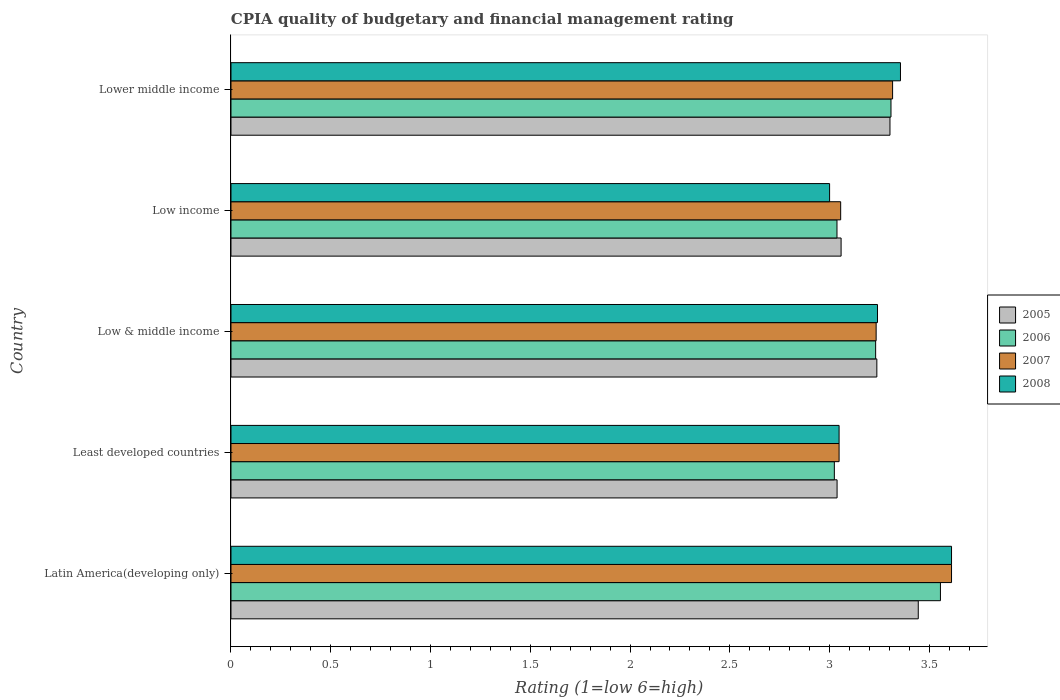How many different coloured bars are there?
Ensure brevity in your answer.  4. How many groups of bars are there?
Your answer should be compact. 5. How many bars are there on the 4th tick from the top?
Give a very brief answer. 4. What is the label of the 2nd group of bars from the top?
Your answer should be very brief. Low income. What is the CPIA rating in 2005 in Latin America(developing only)?
Provide a succinct answer. 3.44. Across all countries, what is the maximum CPIA rating in 2005?
Offer a terse response. 3.44. Across all countries, what is the minimum CPIA rating in 2005?
Make the answer very short. 3.04. In which country was the CPIA rating in 2007 maximum?
Your response must be concise. Latin America(developing only). In which country was the CPIA rating in 2006 minimum?
Make the answer very short. Least developed countries. What is the total CPIA rating in 2006 in the graph?
Your answer should be compact. 16.15. What is the difference between the CPIA rating in 2008 in Latin America(developing only) and that in Lower middle income?
Offer a terse response. 0.26. What is the difference between the CPIA rating in 2007 in Lower middle income and the CPIA rating in 2005 in Least developed countries?
Your response must be concise. 0.28. What is the average CPIA rating in 2007 per country?
Your answer should be compact. 3.25. What is the difference between the CPIA rating in 2005 and CPIA rating in 2007 in Lower middle income?
Your response must be concise. -0.01. In how many countries, is the CPIA rating in 2006 greater than 2.4 ?
Ensure brevity in your answer.  5. What is the ratio of the CPIA rating in 2005 in Low & middle income to that in Low income?
Your answer should be compact. 1.06. What is the difference between the highest and the second highest CPIA rating in 2005?
Offer a very short reply. 0.14. What is the difference between the highest and the lowest CPIA rating in 2005?
Your response must be concise. 0.41. In how many countries, is the CPIA rating in 2007 greater than the average CPIA rating in 2007 taken over all countries?
Offer a terse response. 2. Is the sum of the CPIA rating in 2007 in Latin America(developing only) and Low income greater than the maximum CPIA rating in 2005 across all countries?
Offer a terse response. Yes. Is it the case that in every country, the sum of the CPIA rating in 2005 and CPIA rating in 2008 is greater than the sum of CPIA rating in 2007 and CPIA rating in 2006?
Provide a succinct answer. No. What does the 3rd bar from the top in Low & middle income represents?
Provide a succinct answer. 2006. What does the 2nd bar from the bottom in Least developed countries represents?
Provide a succinct answer. 2006. Is it the case that in every country, the sum of the CPIA rating in 2006 and CPIA rating in 2008 is greater than the CPIA rating in 2007?
Make the answer very short. Yes. Are all the bars in the graph horizontal?
Ensure brevity in your answer.  Yes. How many countries are there in the graph?
Your answer should be compact. 5. What is the difference between two consecutive major ticks on the X-axis?
Provide a short and direct response. 0.5. Are the values on the major ticks of X-axis written in scientific E-notation?
Your answer should be very brief. No. Does the graph contain grids?
Provide a short and direct response. No. Where does the legend appear in the graph?
Make the answer very short. Center right. How are the legend labels stacked?
Give a very brief answer. Vertical. What is the title of the graph?
Offer a very short reply. CPIA quality of budgetary and financial management rating. What is the Rating (1=low 6=high) of 2005 in Latin America(developing only)?
Ensure brevity in your answer.  3.44. What is the Rating (1=low 6=high) in 2006 in Latin America(developing only)?
Ensure brevity in your answer.  3.56. What is the Rating (1=low 6=high) of 2007 in Latin America(developing only)?
Your response must be concise. 3.61. What is the Rating (1=low 6=high) of 2008 in Latin America(developing only)?
Provide a succinct answer. 3.61. What is the Rating (1=low 6=high) of 2005 in Least developed countries?
Offer a terse response. 3.04. What is the Rating (1=low 6=high) in 2006 in Least developed countries?
Keep it short and to the point. 3.02. What is the Rating (1=low 6=high) of 2007 in Least developed countries?
Provide a short and direct response. 3.05. What is the Rating (1=low 6=high) in 2008 in Least developed countries?
Provide a succinct answer. 3.05. What is the Rating (1=low 6=high) of 2005 in Low & middle income?
Provide a succinct answer. 3.24. What is the Rating (1=low 6=high) of 2006 in Low & middle income?
Give a very brief answer. 3.23. What is the Rating (1=low 6=high) of 2007 in Low & middle income?
Offer a very short reply. 3.23. What is the Rating (1=low 6=high) of 2008 in Low & middle income?
Provide a succinct answer. 3.24. What is the Rating (1=low 6=high) in 2005 in Low income?
Provide a succinct answer. 3.06. What is the Rating (1=low 6=high) of 2006 in Low income?
Make the answer very short. 3.04. What is the Rating (1=low 6=high) of 2007 in Low income?
Provide a succinct answer. 3.06. What is the Rating (1=low 6=high) of 2008 in Low income?
Offer a terse response. 3. What is the Rating (1=low 6=high) in 2005 in Lower middle income?
Your answer should be very brief. 3.3. What is the Rating (1=low 6=high) of 2006 in Lower middle income?
Your answer should be very brief. 3.31. What is the Rating (1=low 6=high) of 2007 in Lower middle income?
Give a very brief answer. 3.32. What is the Rating (1=low 6=high) in 2008 in Lower middle income?
Your answer should be very brief. 3.36. Across all countries, what is the maximum Rating (1=low 6=high) of 2005?
Your answer should be compact. 3.44. Across all countries, what is the maximum Rating (1=low 6=high) of 2006?
Your response must be concise. 3.56. Across all countries, what is the maximum Rating (1=low 6=high) in 2007?
Keep it short and to the point. 3.61. Across all countries, what is the maximum Rating (1=low 6=high) of 2008?
Ensure brevity in your answer.  3.61. Across all countries, what is the minimum Rating (1=low 6=high) in 2005?
Give a very brief answer. 3.04. Across all countries, what is the minimum Rating (1=low 6=high) in 2006?
Give a very brief answer. 3.02. Across all countries, what is the minimum Rating (1=low 6=high) in 2007?
Your response must be concise. 3.05. Across all countries, what is the minimum Rating (1=low 6=high) in 2008?
Offer a terse response. 3. What is the total Rating (1=low 6=high) of 2005 in the graph?
Offer a terse response. 16.08. What is the total Rating (1=low 6=high) in 2006 in the graph?
Your response must be concise. 16.15. What is the total Rating (1=low 6=high) in 2007 in the graph?
Ensure brevity in your answer.  16.26. What is the total Rating (1=low 6=high) of 2008 in the graph?
Make the answer very short. 16.25. What is the difference between the Rating (1=low 6=high) of 2005 in Latin America(developing only) and that in Least developed countries?
Give a very brief answer. 0.41. What is the difference between the Rating (1=low 6=high) of 2006 in Latin America(developing only) and that in Least developed countries?
Give a very brief answer. 0.53. What is the difference between the Rating (1=low 6=high) in 2007 in Latin America(developing only) and that in Least developed countries?
Make the answer very short. 0.56. What is the difference between the Rating (1=low 6=high) of 2008 in Latin America(developing only) and that in Least developed countries?
Your answer should be very brief. 0.56. What is the difference between the Rating (1=low 6=high) in 2005 in Latin America(developing only) and that in Low & middle income?
Give a very brief answer. 0.21. What is the difference between the Rating (1=low 6=high) in 2006 in Latin America(developing only) and that in Low & middle income?
Provide a succinct answer. 0.32. What is the difference between the Rating (1=low 6=high) in 2007 in Latin America(developing only) and that in Low & middle income?
Your answer should be compact. 0.38. What is the difference between the Rating (1=low 6=high) in 2008 in Latin America(developing only) and that in Low & middle income?
Your answer should be compact. 0.37. What is the difference between the Rating (1=low 6=high) in 2005 in Latin America(developing only) and that in Low income?
Offer a terse response. 0.39. What is the difference between the Rating (1=low 6=high) of 2006 in Latin America(developing only) and that in Low income?
Provide a short and direct response. 0.52. What is the difference between the Rating (1=low 6=high) in 2007 in Latin America(developing only) and that in Low income?
Ensure brevity in your answer.  0.56. What is the difference between the Rating (1=low 6=high) of 2008 in Latin America(developing only) and that in Low income?
Provide a short and direct response. 0.61. What is the difference between the Rating (1=low 6=high) in 2005 in Latin America(developing only) and that in Lower middle income?
Provide a succinct answer. 0.14. What is the difference between the Rating (1=low 6=high) in 2006 in Latin America(developing only) and that in Lower middle income?
Offer a very short reply. 0.25. What is the difference between the Rating (1=low 6=high) in 2007 in Latin America(developing only) and that in Lower middle income?
Your answer should be compact. 0.3. What is the difference between the Rating (1=low 6=high) in 2008 in Latin America(developing only) and that in Lower middle income?
Offer a very short reply. 0.26. What is the difference between the Rating (1=low 6=high) of 2005 in Least developed countries and that in Low & middle income?
Make the answer very short. -0.2. What is the difference between the Rating (1=low 6=high) of 2006 in Least developed countries and that in Low & middle income?
Your answer should be compact. -0.21. What is the difference between the Rating (1=low 6=high) in 2007 in Least developed countries and that in Low & middle income?
Provide a short and direct response. -0.19. What is the difference between the Rating (1=low 6=high) in 2008 in Least developed countries and that in Low & middle income?
Give a very brief answer. -0.19. What is the difference between the Rating (1=low 6=high) of 2005 in Least developed countries and that in Low income?
Give a very brief answer. -0.02. What is the difference between the Rating (1=low 6=high) in 2006 in Least developed countries and that in Low income?
Keep it short and to the point. -0.01. What is the difference between the Rating (1=low 6=high) in 2007 in Least developed countries and that in Low income?
Offer a very short reply. -0.01. What is the difference between the Rating (1=low 6=high) in 2008 in Least developed countries and that in Low income?
Your answer should be compact. 0.05. What is the difference between the Rating (1=low 6=high) in 2005 in Least developed countries and that in Lower middle income?
Provide a short and direct response. -0.27. What is the difference between the Rating (1=low 6=high) in 2006 in Least developed countries and that in Lower middle income?
Offer a terse response. -0.28. What is the difference between the Rating (1=low 6=high) of 2007 in Least developed countries and that in Lower middle income?
Give a very brief answer. -0.27. What is the difference between the Rating (1=low 6=high) in 2008 in Least developed countries and that in Lower middle income?
Offer a terse response. -0.31. What is the difference between the Rating (1=low 6=high) in 2005 in Low & middle income and that in Low income?
Ensure brevity in your answer.  0.18. What is the difference between the Rating (1=low 6=high) of 2006 in Low & middle income and that in Low income?
Your answer should be compact. 0.19. What is the difference between the Rating (1=low 6=high) in 2007 in Low & middle income and that in Low income?
Give a very brief answer. 0.18. What is the difference between the Rating (1=low 6=high) of 2008 in Low & middle income and that in Low income?
Provide a short and direct response. 0.24. What is the difference between the Rating (1=low 6=high) in 2005 in Low & middle income and that in Lower middle income?
Make the answer very short. -0.07. What is the difference between the Rating (1=low 6=high) of 2006 in Low & middle income and that in Lower middle income?
Your answer should be very brief. -0.08. What is the difference between the Rating (1=low 6=high) of 2007 in Low & middle income and that in Lower middle income?
Your response must be concise. -0.08. What is the difference between the Rating (1=low 6=high) in 2008 in Low & middle income and that in Lower middle income?
Make the answer very short. -0.12. What is the difference between the Rating (1=low 6=high) of 2005 in Low income and that in Lower middle income?
Give a very brief answer. -0.24. What is the difference between the Rating (1=low 6=high) in 2006 in Low income and that in Lower middle income?
Make the answer very short. -0.27. What is the difference between the Rating (1=low 6=high) of 2007 in Low income and that in Lower middle income?
Keep it short and to the point. -0.26. What is the difference between the Rating (1=low 6=high) in 2008 in Low income and that in Lower middle income?
Keep it short and to the point. -0.36. What is the difference between the Rating (1=low 6=high) of 2005 in Latin America(developing only) and the Rating (1=low 6=high) of 2006 in Least developed countries?
Offer a very short reply. 0.42. What is the difference between the Rating (1=low 6=high) of 2005 in Latin America(developing only) and the Rating (1=low 6=high) of 2007 in Least developed countries?
Your answer should be very brief. 0.4. What is the difference between the Rating (1=low 6=high) in 2005 in Latin America(developing only) and the Rating (1=low 6=high) in 2008 in Least developed countries?
Provide a succinct answer. 0.4. What is the difference between the Rating (1=low 6=high) of 2006 in Latin America(developing only) and the Rating (1=low 6=high) of 2007 in Least developed countries?
Provide a succinct answer. 0.51. What is the difference between the Rating (1=low 6=high) of 2006 in Latin America(developing only) and the Rating (1=low 6=high) of 2008 in Least developed countries?
Your response must be concise. 0.51. What is the difference between the Rating (1=low 6=high) of 2007 in Latin America(developing only) and the Rating (1=low 6=high) of 2008 in Least developed countries?
Keep it short and to the point. 0.56. What is the difference between the Rating (1=low 6=high) of 2005 in Latin America(developing only) and the Rating (1=low 6=high) of 2006 in Low & middle income?
Make the answer very short. 0.21. What is the difference between the Rating (1=low 6=high) in 2005 in Latin America(developing only) and the Rating (1=low 6=high) in 2007 in Low & middle income?
Provide a short and direct response. 0.21. What is the difference between the Rating (1=low 6=high) of 2005 in Latin America(developing only) and the Rating (1=low 6=high) of 2008 in Low & middle income?
Ensure brevity in your answer.  0.2. What is the difference between the Rating (1=low 6=high) of 2006 in Latin America(developing only) and the Rating (1=low 6=high) of 2007 in Low & middle income?
Your answer should be very brief. 0.32. What is the difference between the Rating (1=low 6=high) in 2006 in Latin America(developing only) and the Rating (1=low 6=high) in 2008 in Low & middle income?
Ensure brevity in your answer.  0.32. What is the difference between the Rating (1=low 6=high) in 2007 in Latin America(developing only) and the Rating (1=low 6=high) in 2008 in Low & middle income?
Ensure brevity in your answer.  0.37. What is the difference between the Rating (1=low 6=high) in 2005 in Latin America(developing only) and the Rating (1=low 6=high) in 2006 in Low income?
Offer a very short reply. 0.41. What is the difference between the Rating (1=low 6=high) in 2005 in Latin America(developing only) and the Rating (1=low 6=high) in 2007 in Low income?
Your answer should be compact. 0.39. What is the difference between the Rating (1=low 6=high) of 2005 in Latin America(developing only) and the Rating (1=low 6=high) of 2008 in Low income?
Ensure brevity in your answer.  0.44. What is the difference between the Rating (1=low 6=high) in 2006 in Latin America(developing only) and the Rating (1=low 6=high) in 2008 in Low income?
Make the answer very short. 0.56. What is the difference between the Rating (1=low 6=high) of 2007 in Latin America(developing only) and the Rating (1=low 6=high) of 2008 in Low income?
Provide a short and direct response. 0.61. What is the difference between the Rating (1=low 6=high) of 2005 in Latin America(developing only) and the Rating (1=low 6=high) of 2006 in Lower middle income?
Keep it short and to the point. 0.14. What is the difference between the Rating (1=low 6=high) in 2005 in Latin America(developing only) and the Rating (1=low 6=high) in 2007 in Lower middle income?
Make the answer very short. 0.13. What is the difference between the Rating (1=low 6=high) of 2005 in Latin America(developing only) and the Rating (1=low 6=high) of 2008 in Lower middle income?
Keep it short and to the point. 0.09. What is the difference between the Rating (1=low 6=high) of 2006 in Latin America(developing only) and the Rating (1=low 6=high) of 2007 in Lower middle income?
Your response must be concise. 0.24. What is the difference between the Rating (1=low 6=high) of 2006 in Latin America(developing only) and the Rating (1=low 6=high) of 2008 in Lower middle income?
Your answer should be compact. 0.2. What is the difference between the Rating (1=low 6=high) of 2007 in Latin America(developing only) and the Rating (1=low 6=high) of 2008 in Lower middle income?
Your answer should be very brief. 0.26. What is the difference between the Rating (1=low 6=high) of 2005 in Least developed countries and the Rating (1=low 6=high) of 2006 in Low & middle income?
Provide a short and direct response. -0.19. What is the difference between the Rating (1=low 6=high) of 2005 in Least developed countries and the Rating (1=low 6=high) of 2007 in Low & middle income?
Your answer should be compact. -0.2. What is the difference between the Rating (1=low 6=high) of 2005 in Least developed countries and the Rating (1=low 6=high) of 2008 in Low & middle income?
Provide a short and direct response. -0.2. What is the difference between the Rating (1=low 6=high) of 2006 in Least developed countries and the Rating (1=low 6=high) of 2007 in Low & middle income?
Your answer should be very brief. -0.21. What is the difference between the Rating (1=low 6=high) of 2006 in Least developed countries and the Rating (1=low 6=high) of 2008 in Low & middle income?
Your answer should be compact. -0.22. What is the difference between the Rating (1=low 6=high) in 2007 in Least developed countries and the Rating (1=low 6=high) in 2008 in Low & middle income?
Ensure brevity in your answer.  -0.19. What is the difference between the Rating (1=low 6=high) of 2005 in Least developed countries and the Rating (1=low 6=high) of 2007 in Low income?
Give a very brief answer. -0.02. What is the difference between the Rating (1=low 6=high) of 2005 in Least developed countries and the Rating (1=low 6=high) of 2008 in Low income?
Provide a succinct answer. 0.04. What is the difference between the Rating (1=low 6=high) of 2006 in Least developed countries and the Rating (1=low 6=high) of 2007 in Low income?
Provide a short and direct response. -0.03. What is the difference between the Rating (1=low 6=high) in 2006 in Least developed countries and the Rating (1=low 6=high) in 2008 in Low income?
Your response must be concise. 0.02. What is the difference between the Rating (1=low 6=high) in 2007 in Least developed countries and the Rating (1=low 6=high) in 2008 in Low income?
Keep it short and to the point. 0.05. What is the difference between the Rating (1=low 6=high) of 2005 in Least developed countries and the Rating (1=low 6=high) of 2006 in Lower middle income?
Make the answer very short. -0.27. What is the difference between the Rating (1=low 6=high) of 2005 in Least developed countries and the Rating (1=low 6=high) of 2007 in Lower middle income?
Ensure brevity in your answer.  -0.28. What is the difference between the Rating (1=low 6=high) of 2005 in Least developed countries and the Rating (1=low 6=high) of 2008 in Lower middle income?
Offer a terse response. -0.32. What is the difference between the Rating (1=low 6=high) in 2006 in Least developed countries and the Rating (1=low 6=high) in 2007 in Lower middle income?
Your answer should be very brief. -0.29. What is the difference between the Rating (1=low 6=high) of 2006 in Least developed countries and the Rating (1=low 6=high) of 2008 in Lower middle income?
Provide a succinct answer. -0.33. What is the difference between the Rating (1=low 6=high) in 2007 in Least developed countries and the Rating (1=low 6=high) in 2008 in Lower middle income?
Your response must be concise. -0.31. What is the difference between the Rating (1=low 6=high) of 2005 in Low & middle income and the Rating (1=low 6=high) of 2006 in Low income?
Offer a very short reply. 0.2. What is the difference between the Rating (1=low 6=high) in 2005 in Low & middle income and the Rating (1=low 6=high) in 2007 in Low income?
Your response must be concise. 0.18. What is the difference between the Rating (1=low 6=high) in 2005 in Low & middle income and the Rating (1=low 6=high) in 2008 in Low income?
Provide a short and direct response. 0.24. What is the difference between the Rating (1=low 6=high) in 2006 in Low & middle income and the Rating (1=low 6=high) in 2007 in Low income?
Make the answer very short. 0.18. What is the difference between the Rating (1=low 6=high) in 2006 in Low & middle income and the Rating (1=low 6=high) in 2008 in Low income?
Ensure brevity in your answer.  0.23. What is the difference between the Rating (1=low 6=high) in 2007 in Low & middle income and the Rating (1=low 6=high) in 2008 in Low income?
Provide a short and direct response. 0.23. What is the difference between the Rating (1=low 6=high) in 2005 in Low & middle income and the Rating (1=low 6=high) in 2006 in Lower middle income?
Your answer should be compact. -0.07. What is the difference between the Rating (1=low 6=high) in 2005 in Low & middle income and the Rating (1=low 6=high) in 2007 in Lower middle income?
Your response must be concise. -0.08. What is the difference between the Rating (1=low 6=high) of 2005 in Low & middle income and the Rating (1=low 6=high) of 2008 in Lower middle income?
Make the answer very short. -0.12. What is the difference between the Rating (1=low 6=high) of 2006 in Low & middle income and the Rating (1=low 6=high) of 2007 in Lower middle income?
Offer a very short reply. -0.09. What is the difference between the Rating (1=low 6=high) of 2006 in Low & middle income and the Rating (1=low 6=high) of 2008 in Lower middle income?
Give a very brief answer. -0.12. What is the difference between the Rating (1=low 6=high) in 2007 in Low & middle income and the Rating (1=low 6=high) in 2008 in Lower middle income?
Your answer should be very brief. -0.12. What is the difference between the Rating (1=low 6=high) in 2005 in Low income and the Rating (1=low 6=high) in 2007 in Lower middle income?
Keep it short and to the point. -0.26. What is the difference between the Rating (1=low 6=high) of 2005 in Low income and the Rating (1=low 6=high) of 2008 in Lower middle income?
Provide a short and direct response. -0.3. What is the difference between the Rating (1=low 6=high) of 2006 in Low income and the Rating (1=low 6=high) of 2007 in Lower middle income?
Provide a succinct answer. -0.28. What is the difference between the Rating (1=low 6=high) in 2006 in Low income and the Rating (1=low 6=high) in 2008 in Lower middle income?
Keep it short and to the point. -0.32. What is the difference between the Rating (1=low 6=high) in 2007 in Low income and the Rating (1=low 6=high) in 2008 in Lower middle income?
Offer a terse response. -0.3. What is the average Rating (1=low 6=high) in 2005 per country?
Your response must be concise. 3.22. What is the average Rating (1=low 6=high) in 2006 per country?
Provide a short and direct response. 3.23. What is the average Rating (1=low 6=high) of 2007 per country?
Keep it short and to the point. 3.25. What is the average Rating (1=low 6=high) of 2008 per country?
Ensure brevity in your answer.  3.25. What is the difference between the Rating (1=low 6=high) in 2005 and Rating (1=low 6=high) in 2006 in Latin America(developing only)?
Give a very brief answer. -0.11. What is the difference between the Rating (1=low 6=high) of 2005 and Rating (1=low 6=high) of 2007 in Latin America(developing only)?
Your answer should be compact. -0.17. What is the difference between the Rating (1=low 6=high) in 2006 and Rating (1=low 6=high) in 2007 in Latin America(developing only)?
Give a very brief answer. -0.06. What is the difference between the Rating (1=low 6=high) of 2006 and Rating (1=low 6=high) of 2008 in Latin America(developing only)?
Provide a succinct answer. -0.06. What is the difference between the Rating (1=low 6=high) of 2007 and Rating (1=low 6=high) of 2008 in Latin America(developing only)?
Offer a terse response. 0. What is the difference between the Rating (1=low 6=high) in 2005 and Rating (1=low 6=high) in 2006 in Least developed countries?
Offer a terse response. 0.01. What is the difference between the Rating (1=low 6=high) in 2005 and Rating (1=low 6=high) in 2007 in Least developed countries?
Your answer should be compact. -0.01. What is the difference between the Rating (1=low 6=high) of 2005 and Rating (1=low 6=high) of 2008 in Least developed countries?
Make the answer very short. -0.01. What is the difference between the Rating (1=low 6=high) in 2006 and Rating (1=low 6=high) in 2007 in Least developed countries?
Ensure brevity in your answer.  -0.02. What is the difference between the Rating (1=low 6=high) in 2006 and Rating (1=low 6=high) in 2008 in Least developed countries?
Your answer should be very brief. -0.02. What is the difference between the Rating (1=low 6=high) in 2005 and Rating (1=low 6=high) in 2006 in Low & middle income?
Make the answer very short. 0.01. What is the difference between the Rating (1=low 6=high) in 2005 and Rating (1=low 6=high) in 2007 in Low & middle income?
Keep it short and to the point. 0. What is the difference between the Rating (1=low 6=high) in 2005 and Rating (1=low 6=high) in 2008 in Low & middle income?
Your answer should be compact. -0. What is the difference between the Rating (1=low 6=high) of 2006 and Rating (1=low 6=high) of 2007 in Low & middle income?
Your response must be concise. -0. What is the difference between the Rating (1=low 6=high) in 2006 and Rating (1=low 6=high) in 2008 in Low & middle income?
Your response must be concise. -0.01. What is the difference between the Rating (1=low 6=high) of 2007 and Rating (1=low 6=high) of 2008 in Low & middle income?
Ensure brevity in your answer.  -0.01. What is the difference between the Rating (1=low 6=high) of 2005 and Rating (1=low 6=high) of 2006 in Low income?
Make the answer very short. 0.02. What is the difference between the Rating (1=low 6=high) of 2005 and Rating (1=low 6=high) of 2007 in Low income?
Provide a short and direct response. 0. What is the difference between the Rating (1=low 6=high) of 2005 and Rating (1=low 6=high) of 2008 in Low income?
Your answer should be very brief. 0.06. What is the difference between the Rating (1=low 6=high) of 2006 and Rating (1=low 6=high) of 2007 in Low income?
Your answer should be very brief. -0.02. What is the difference between the Rating (1=low 6=high) in 2006 and Rating (1=low 6=high) in 2008 in Low income?
Your answer should be very brief. 0.04. What is the difference between the Rating (1=low 6=high) of 2007 and Rating (1=low 6=high) of 2008 in Low income?
Your answer should be very brief. 0.06. What is the difference between the Rating (1=low 6=high) of 2005 and Rating (1=low 6=high) of 2006 in Lower middle income?
Offer a very short reply. -0.01. What is the difference between the Rating (1=low 6=high) of 2005 and Rating (1=low 6=high) of 2007 in Lower middle income?
Offer a very short reply. -0.01. What is the difference between the Rating (1=low 6=high) in 2005 and Rating (1=low 6=high) in 2008 in Lower middle income?
Offer a terse response. -0.05. What is the difference between the Rating (1=low 6=high) in 2006 and Rating (1=low 6=high) in 2007 in Lower middle income?
Give a very brief answer. -0.01. What is the difference between the Rating (1=low 6=high) in 2006 and Rating (1=low 6=high) in 2008 in Lower middle income?
Provide a succinct answer. -0.05. What is the difference between the Rating (1=low 6=high) of 2007 and Rating (1=low 6=high) of 2008 in Lower middle income?
Provide a succinct answer. -0.04. What is the ratio of the Rating (1=low 6=high) in 2005 in Latin America(developing only) to that in Least developed countries?
Provide a succinct answer. 1.13. What is the ratio of the Rating (1=low 6=high) of 2006 in Latin America(developing only) to that in Least developed countries?
Your answer should be very brief. 1.18. What is the ratio of the Rating (1=low 6=high) in 2007 in Latin America(developing only) to that in Least developed countries?
Your response must be concise. 1.18. What is the ratio of the Rating (1=low 6=high) in 2008 in Latin America(developing only) to that in Least developed countries?
Offer a very short reply. 1.18. What is the ratio of the Rating (1=low 6=high) in 2005 in Latin America(developing only) to that in Low & middle income?
Provide a short and direct response. 1.06. What is the ratio of the Rating (1=low 6=high) of 2006 in Latin America(developing only) to that in Low & middle income?
Ensure brevity in your answer.  1.1. What is the ratio of the Rating (1=low 6=high) in 2007 in Latin America(developing only) to that in Low & middle income?
Offer a very short reply. 1.12. What is the ratio of the Rating (1=low 6=high) of 2008 in Latin America(developing only) to that in Low & middle income?
Your answer should be very brief. 1.11. What is the ratio of the Rating (1=low 6=high) in 2005 in Latin America(developing only) to that in Low income?
Give a very brief answer. 1.13. What is the ratio of the Rating (1=low 6=high) of 2006 in Latin America(developing only) to that in Low income?
Offer a terse response. 1.17. What is the ratio of the Rating (1=low 6=high) of 2007 in Latin America(developing only) to that in Low income?
Keep it short and to the point. 1.18. What is the ratio of the Rating (1=low 6=high) of 2008 in Latin America(developing only) to that in Low income?
Offer a terse response. 1.2. What is the ratio of the Rating (1=low 6=high) in 2005 in Latin America(developing only) to that in Lower middle income?
Your response must be concise. 1.04. What is the ratio of the Rating (1=low 6=high) in 2006 in Latin America(developing only) to that in Lower middle income?
Your response must be concise. 1.07. What is the ratio of the Rating (1=low 6=high) in 2007 in Latin America(developing only) to that in Lower middle income?
Keep it short and to the point. 1.09. What is the ratio of the Rating (1=low 6=high) of 2008 in Latin America(developing only) to that in Lower middle income?
Your answer should be very brief. 1.08. What is the ratio of the Rating (1=low 6=high) in 2005 in Least developed countries to that in Low & middle income?
Ensure brevity in your answer.  0.94. What is the ratio of the Rating (1=low 6=high) in 2006 in Least developed countries to that in Low & middle income?
Your response must be concise. 0.94. What is the ratio of the Rating (1=low 6=high) of 2007 in Least developed countries to that in Low & middle income?
Keep it short and to the point. 0.94. What is the ratio of the Rating (1=low 6=high) in 2008 in Least developed countries to that in Low & middle income?
Provide a short and direct response. 0.94. What is the ratio of the Rating (1=low 6=high) in 2006 in Least developed countries to that in Low income?
Provide a short and direct response. 1. What is the ratio of the Rating (1=low 6=high) of 2008 in Least developed countries to that in Low income?
Ensure brevity in your answer.  1.02. What is the ratio of the Rating (1=low 6=high) of 2005 in Least developed countries to that in Lower middle income?
Provide a short and direct response. 0.92. What is the ratio of the Rating (1=low 6=high) in 2006 in Least developed countries to that in Lower middle income?
Your response must be concise. 0.91. What is the ratio of the Rating (1=low 6=high) of 2007 in Least developed countries to that in Lower middle income?
Make the answer very short. 0.92. What is the ratio of the Rating (1=low 6=high) of 2008 in Least developed countries to that in Lower middle income?
Provide a succinct answer. 0.91. What is the ratio of the Rating (1=low 6=high) in 2005 in Low & middle income to that in Low income?
Offer a very short reply. 1.06. What is the ratio of the Rating (1=low 6=high) in 2006 in Low & middle income to that in Low income?
Your answer should be compact. 1.06. What is the ratio of the Rating (1=low 6=high) in 2007 in Low & middle income to that in Low income?
Provide a succinct answer. 1.06. What is the ratio of the Rating (1=low 6=high) in 2008 in Low & middle income to that in Low income?
Offer a terse response. 1.08. What is the ratio of the Rating (1=low 6=high) of 2005 in Low & middle income to that in Lower middle income?
Give a very brief answer. 0.98. What is the ratio of the Rating (1=low 6=high) of 2006 in Low & middle income to that in Lower middle income?
Your answer should be compact. 0.98. What is the ratio of the Rating (1=low 6=high) in 2007 in Low & middle income to that in Lower middle income?
Your answer should be compact. 0.98. What is the ratio of the Rating (1=low 6=high) of 2008 in Low & middle income to that in Lower middle income?
Provide a succinct answer. 0.97. What is the ratio of the Rating (1=low 6=high) in 2005 in Low income to that in Lower middle income?
Give a very brief answer. 0.93. What is the ratio of the Rating (1=low 6=high) of 2006 in Low income to that in Lower middle income?
Keep it short and to the point. 0.92. What is the ratio of the Rating (1=low 6=high) of 2007 in Low income to that in Lower middle income?
Your answer should be very brief. 0.92. What is the ratio of the Rating (1=low 6=high) of 2008 in Low income to that in Lower middle income?
Your answer should be compact. 0.89. What is the difference between the highest and the second highest Rating (1=low 6=high) of 2005?
Make the answer very short. 0.14. What is the difference between the highest and the second highest Rating (1=low 6=high) of 2006?
Offer a terse response. 0.25. What is the difference between the highest and the second highest Rating (1=low 6=high) of 2007?
Give a very brief answer. 0.3. What is the difference between the highest and the second highest Rating (1=low 6=high) of 2008?
Provide a succinct answer. 0.26. What is the difference between the highest and the lowest Rating (1=low 6=high) in 2005?
Provide a succinct answer. 0.41. What is the difference between the highest and the lowest Rating (1=low 6=high) of 2006?
Provide a short and direct response. 0.53. What is the difference between the highest and the lowest Rating (1=low 6=high) in 2007?
Provide a succinct answer. 0.56. What is the difference between the highest and the lowest Rating (1=low 6=high) of 2008?
Ensure brevity in your answer.  0.61. 